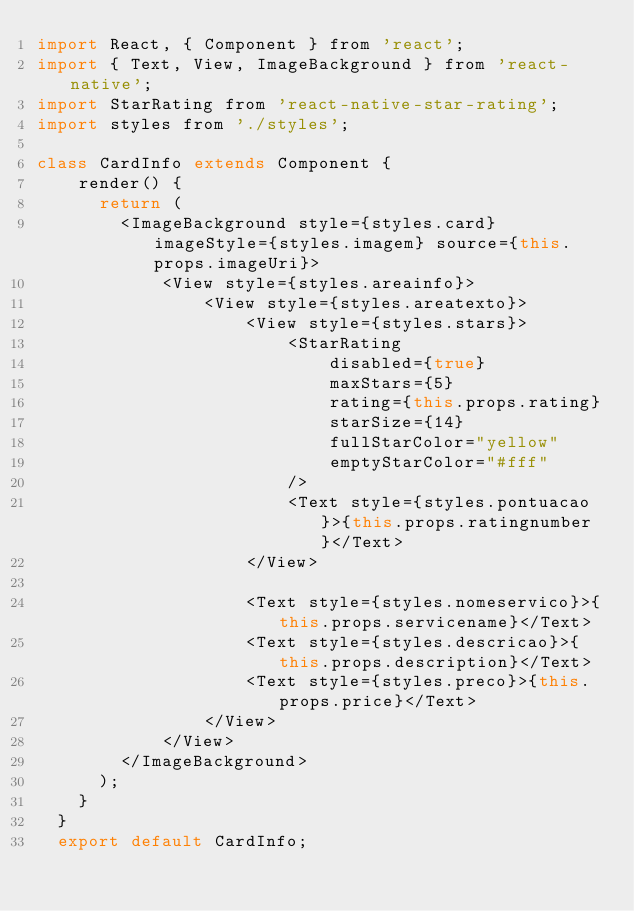<code> <loc_0><loc_0><loc_500><loc_500><_JavaScript_>import React, { Component } from 'react';
import { Text, View, ImageBackground } from 'react-native';
import StarRating from 'react-native-star-rating';
import styles from './styles';

class CardInfo extends Component {
    render() {
      return (
        <ImageBackground style={styles.card} imageStyle={styles.imagem} source={this.props.imageUri}>
            <View style={styles.areainfo}>
                <View style={styles.areatexto}>
                    <View style={styles.stars}>
                        <StarRating
                            disabled={true}
                            maxStars={5}
                            rating={this.props.rating}
                            starSize={14}
                            fullStarColor="yellow"
                            emptyStarColor="#fff"
                        />
                        <Text style={styles.pontuacao}>{this.props.ratingnumber}</Text>
                    </View>
                    
                    <Text style={styles.nomeservico}>{this.props.servicename}</Text>
                    <Text style={styles.descricao}>{this.props.description}</Text>
                    <Text style={styles.preco}>{this.props.price}</Text>
                </View>
            </View>
        </ImageBackground>
      );
    }
  }
  export default CardInfo;</code> 